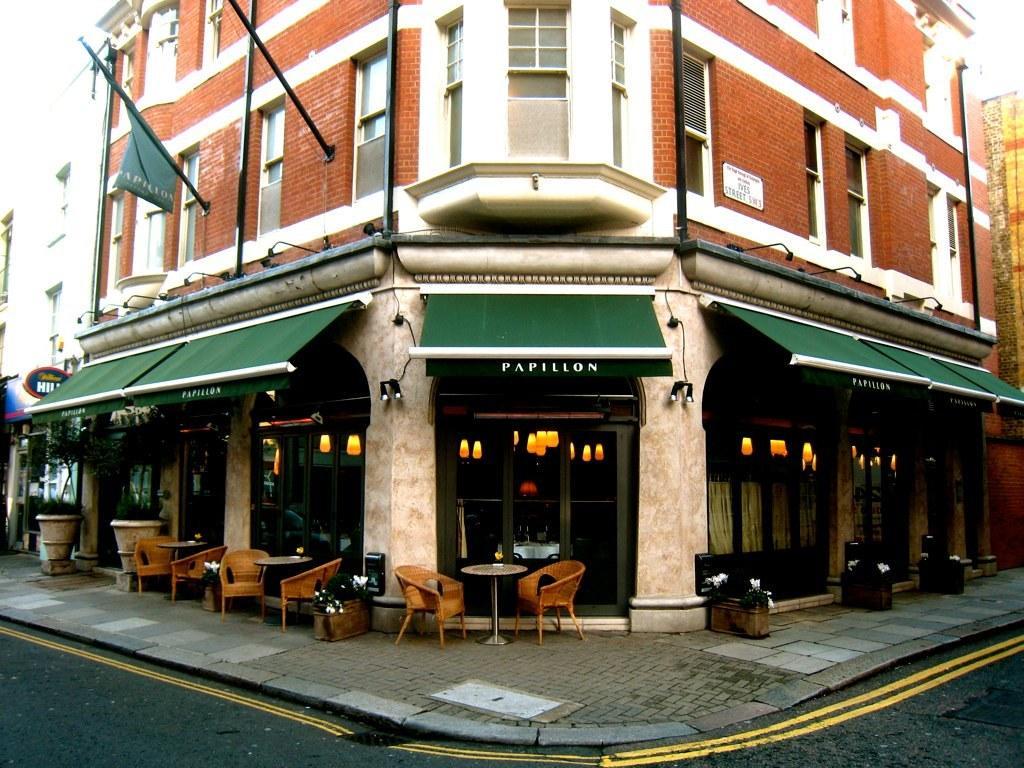How would you summarize this image in a sentence or two? In the image we can see there is a building which is made up of red bricks and in front of it on the footpath there are chairs and tables kept. 